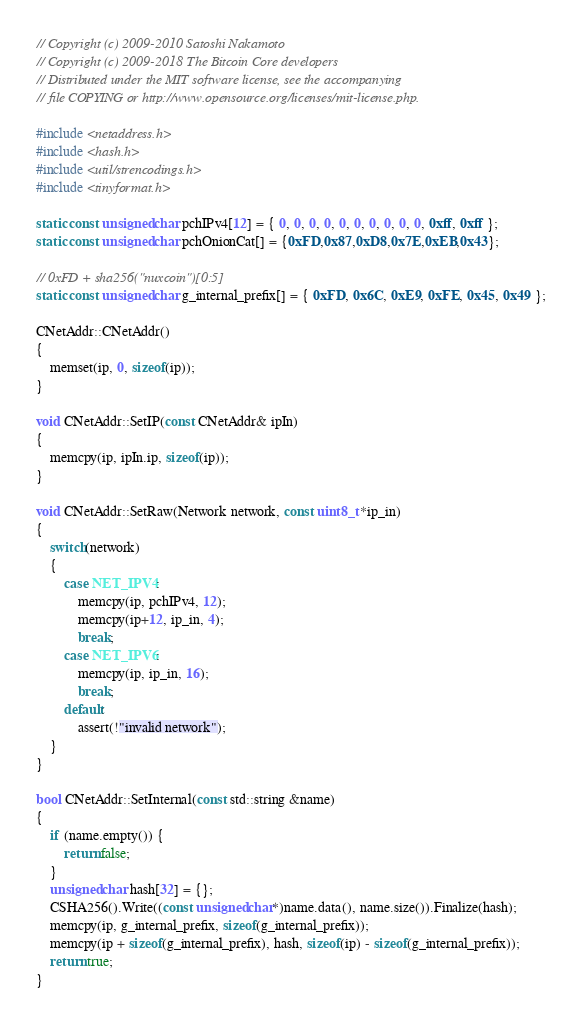Convert code to text. <code><loc_0><loc_0><loc_500><loc_500><_C++_>// Copyright (c) 2009-2010 Satoshi Nakamoto
// Copyright (c) 2009-2018 The Bitcoin Core developers
// Distributed under the MIT software license, see the accompanying
// file COPYING or http://www.opensource.org/licenses/mit-license.php.

#include <netaddress.h>
#include <hash.h>
#include <util/strencodings.h>
#include <tinyformat.h>

static const unsigned char pchIPv4[12] = { 0, 0, 0, 0, 0, 0, 0, 0, 0, 0, 0xff, 0xff };
static const unsigned char pchOnionCat[] = {0xFD,0x87,0xD8,0x7E,0xEB,0x43};

// 0xFD + sha256("nuxcoin")[0:5]
static const unsigned char g_internal_prefix[] = { 0xFD, 0x6C, 0xE9, 0xFE, 0x45, 0x49 };

CNetAddr::CNetAddr()
{
    memset(ip, 0, sizeof(ip));
}

void CNetAddr::SetIP(const CNetAddr& ipIn)
{
    memcpy(ip, ipIn.ip, sizeof(ip));
}

void CNetAddr::SetRaw(Network network, const uint8_t *ip_in)
{
    switch(network)
    {
        case NET_IPV4:
            memcpy(ip, pchIPv4, 12);
            memcpy(ip+12, ip_in, 4);
            break;
        case NET_IPV6:
            memcpy(ip, ip_in, 16);
            break;
        default:
            assert(!"invalid network");
    }
}

bool CNetAddr::SetInternal(const std::string &name)
{
    if (name.empty()) {
        return false;
    }
    unsigned char hash[32] = {};
    CSHA256().Write((const unsigned char*)name.data(), name.size()).Finalize(hash);
    memcpy(ip, g_internal_prefix, sizeof(g_internal_prefix));
    memcpy(ip + sizeof(g_internal_prefix), hash, sizeof(ip) - sizeof(g_internal_prefix));
    return true;
}
</code> 